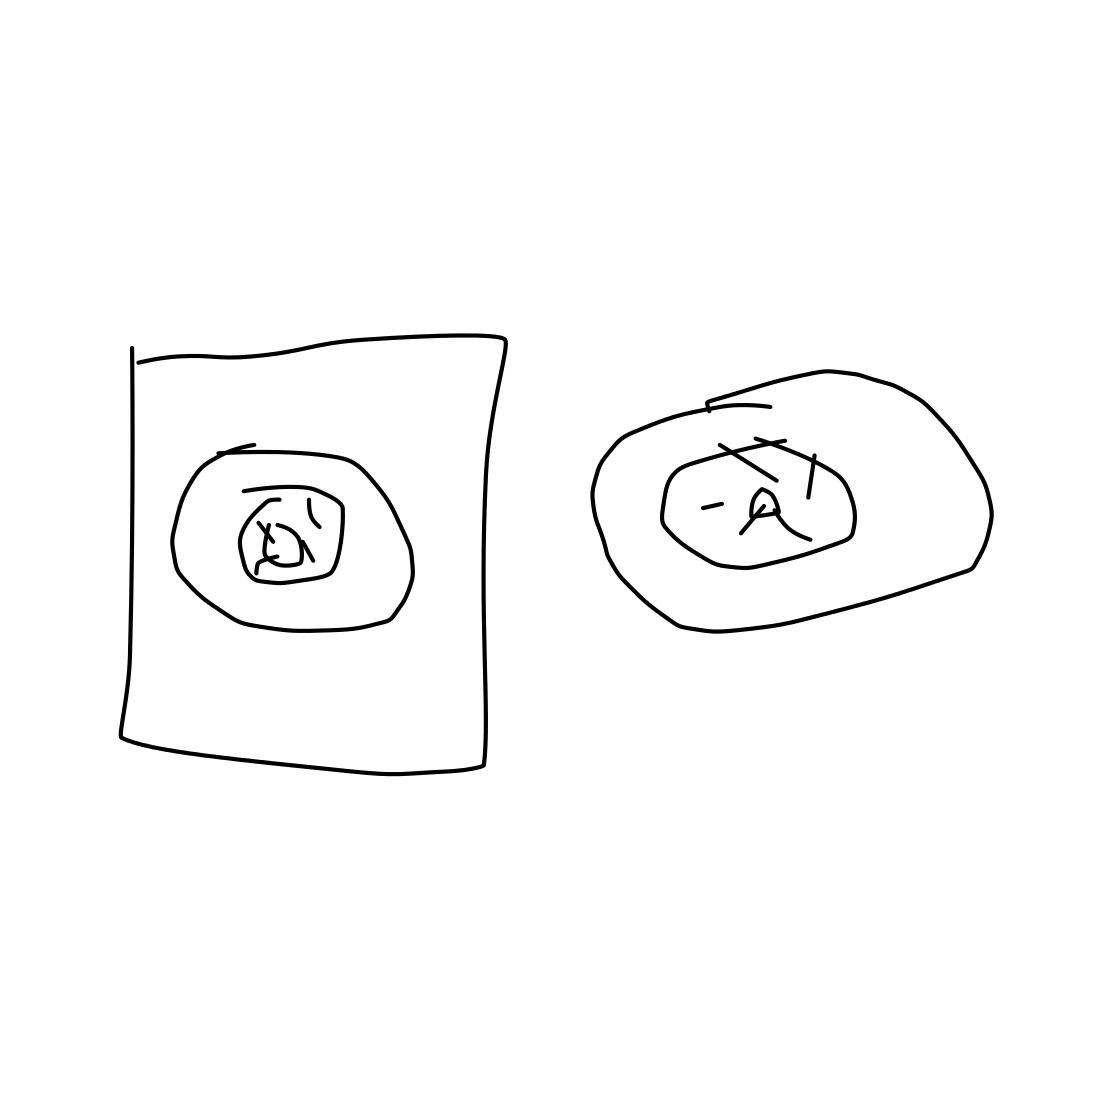Could these drawings have any specific purpose or message? It's difficult to ascertain a specific purpose or message without more context. They might be quick sketches created during brainstorming, or playful drawings without a defined objective. The artist would be the best person to provide insight into their intent. 